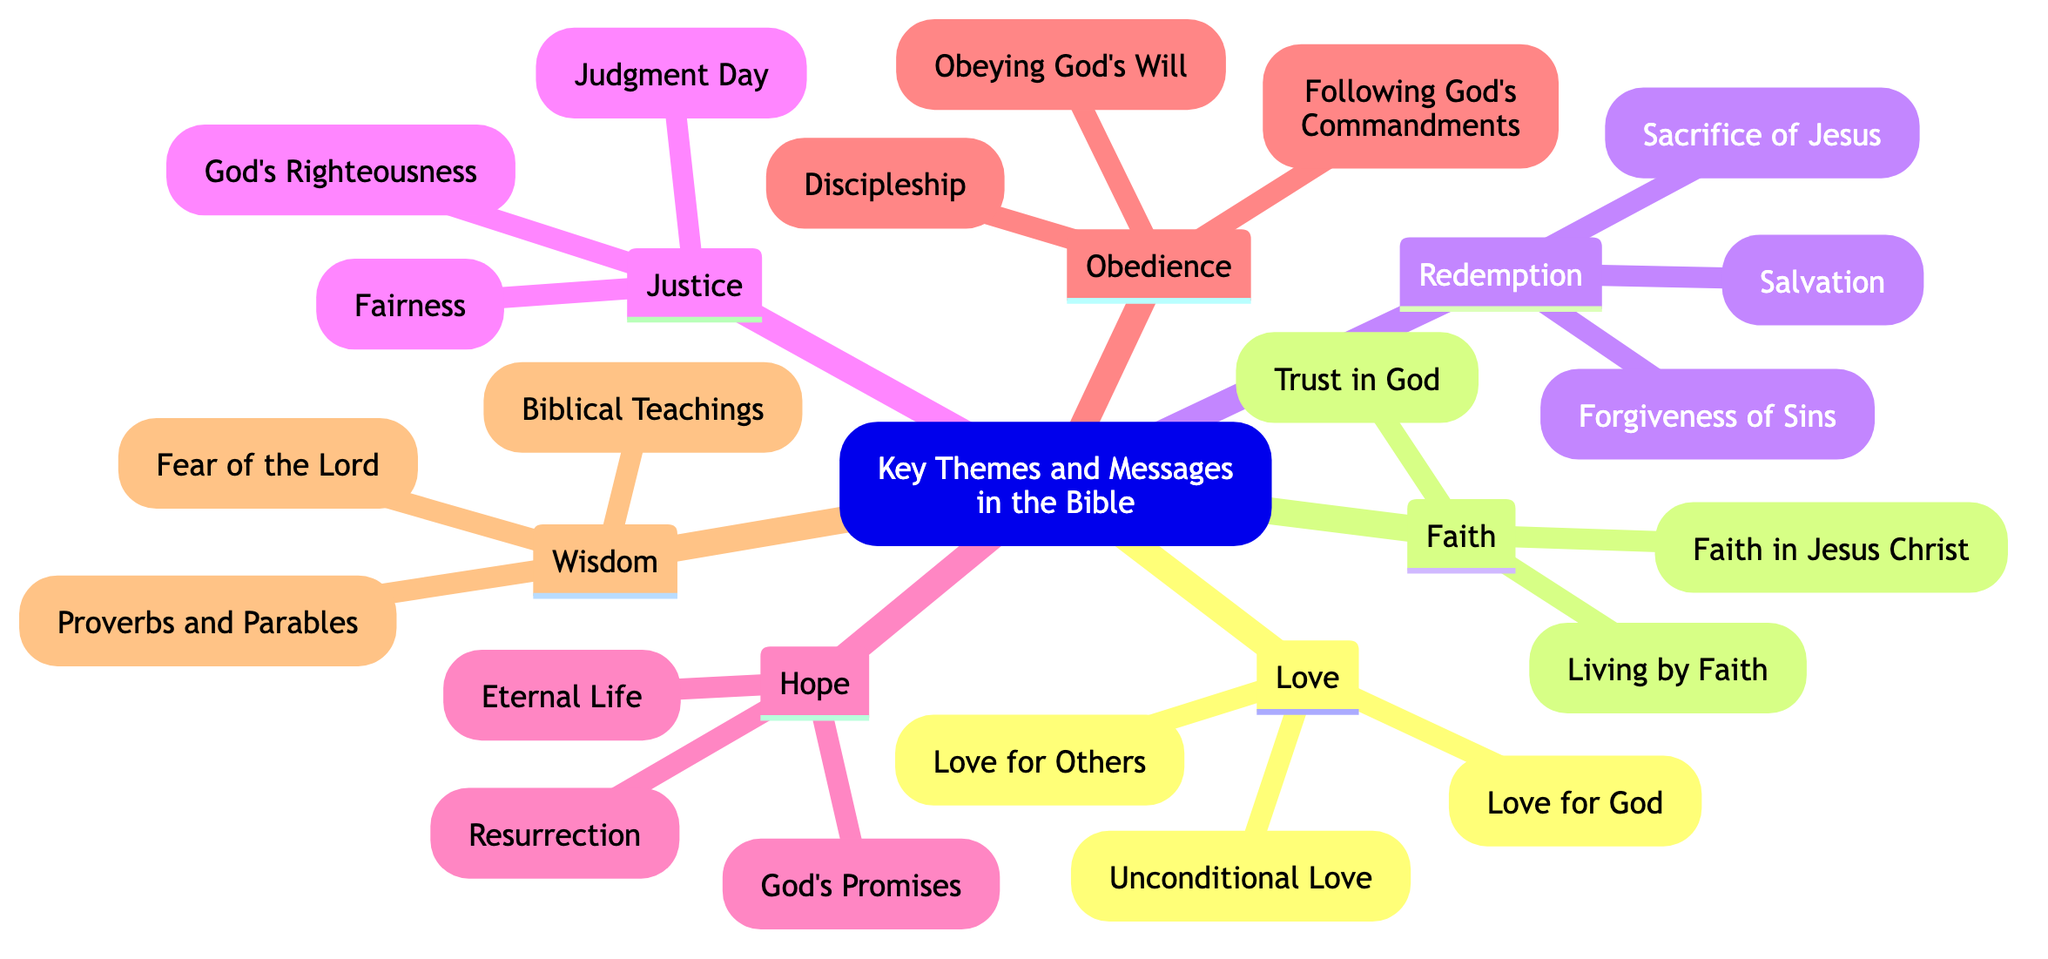What is the root topic of the diagram? The root topic is stated clearly at the beginning of the diagram, which is "Key Themes and Messages in the Bible."
Answer: Key Themes and Messages in the Bible How many main themes are there in the diagram? By counting each of the main branches listed under the root, we find that there are seven distinct themes including Love, Faith, Redemption, Justice, Hope, Obedience, and Wisdom.
Answer: 7 What are the subtopics under the theme of Love? The subtopics under the theme of Love are explicitly listed as "Love for God," "Love for Others," and "Unconditional Love."
Answer: Love for God, Love for Others, Unconditional Love Which theme includes the concept of "Eternal Life"? Looking at the branches, "Eternal Life" is a subtopic under the theme of Hope.
Answer: Hope How many subtopics does the theme of Redemption have? We count the subtopics grouped under Redemption, which are "Sacrifice of Jesus," "Forgiveness of Sins," and "Salvation," leading to a total of three subtopics.
Answer: 3 Which two themes are directly related to the concept of obedience? The themes of Obedience and Faith are directly related, as they both emphasize concepts of following God's will and living by faith, respectively.
Answer: Obedience, Faith What is the relationship between wisdom and the fear of the Lord? The diagram shows that "Fear of the Lord" is a subtopic under the theme of Wisdom, indicating that it is a key aspect of understanding wisdom in a biblical context.
Answer: Fear of the Lord is a subtopic of Wisdom Which theme includes the idea of "Judgment Day"? The concept of "Judgment Day" is detailed under the theme of Justice.
Answer: Justice What is the main focus of the theme of Faith? The theme of Faith centers around trusting in God and having faith in Jesus Christ, along with living by Faith, all of which are explicitly stated as subtopics.
Answer: Trust in God, Faith in Jesus Christ, Living by Faith 